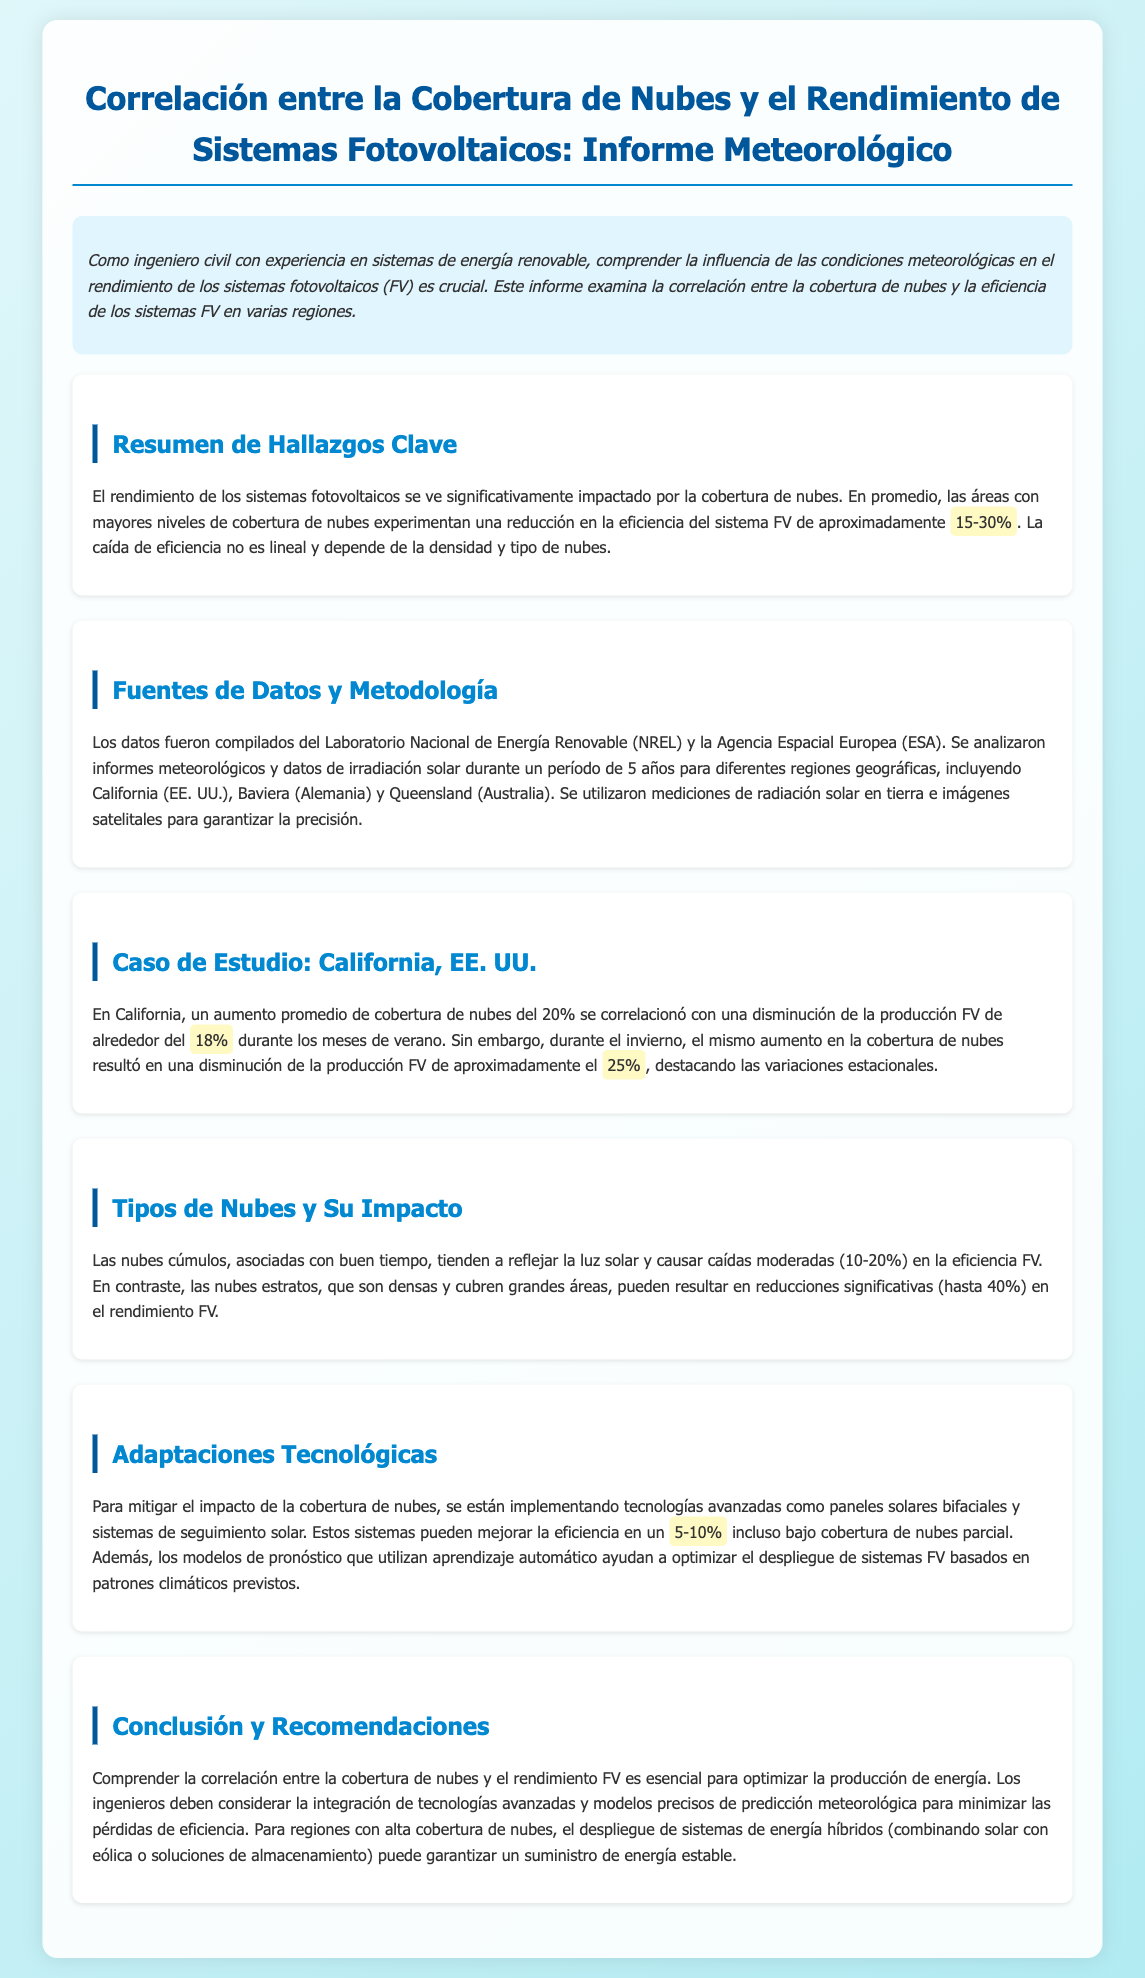¿Qué porcentaje de reducción en la eficiencia del sistema FV se experimenta en áreas con altas nubes? En el documento se indica que la reducción en la eficiencia del sistema FV varía entre 15-30% en áreas con mayor cobertura de nubes.
Answer: 15-30% ¿Cuál es el impacto en la producción FV en California durante el invierno con un aumento del 20% en la cobertura de nubes? El informe menciona que durante el invierno, un aumento del 20% en la cobertura de nubes resultó en una disminución de la producción FV de aproximadamente 25%.
Answer: 25% ¿Qué tipos de nubes causan una caída moderada en la eficiencia FV? Se mencionan las nubes cúmulos, que están asociadas con buen tiempo y causan caídas moderadas en la eficiencia FV.
Answer: Nubes cúmulos ¿Cuál es el nombre del laboratorio de donde se recopilaron parte de los datos? El laboratorio mencionado para la recopilación de datos es el Laboratorio Nacional de Energía Renovable (NREL).
Answer: NREL ¿Qué porcentaje de mejora en eficiencia se puede lograr con tecnologías avanzadas bajo cobertura de nubes parcial? El documento afirma que tecnologías avanzadas como paneles solares bifaciales pueden mejorar la eficiencia en un 5-10% bajo cobertura de nubes parcial.
Answer: 5-10% ¿Cómo se correlaciona el aumento de la cobertura de nubes con la producción FV en los meses de verano en California? En el informe se señala que un aumento del 20% en la cobertura de nubes se correlacionó con una disminución de la producción FV de alrededor del 18% durante los meses de verano.
Answer: 18% ¿Cuál es una recomendación para optimizar la producción de energía en regiones con alta cobertura de nubes? Se recomienda el despliegue de sistemas de energía híbridos para asegurar un suministro de energía estable en regiones con alta cobertura de nubes.
Answer: Sistemas de energía híbridos ¿Qué impacto tienen las nubes estratos en el rendimiento FV? Las nubes estratos, siendo densas y cubriendo grandes áreas, pueden resultar en reducciones significativas en el rendimiento FV, hasta 40%.
Answer: Hasta 40% 